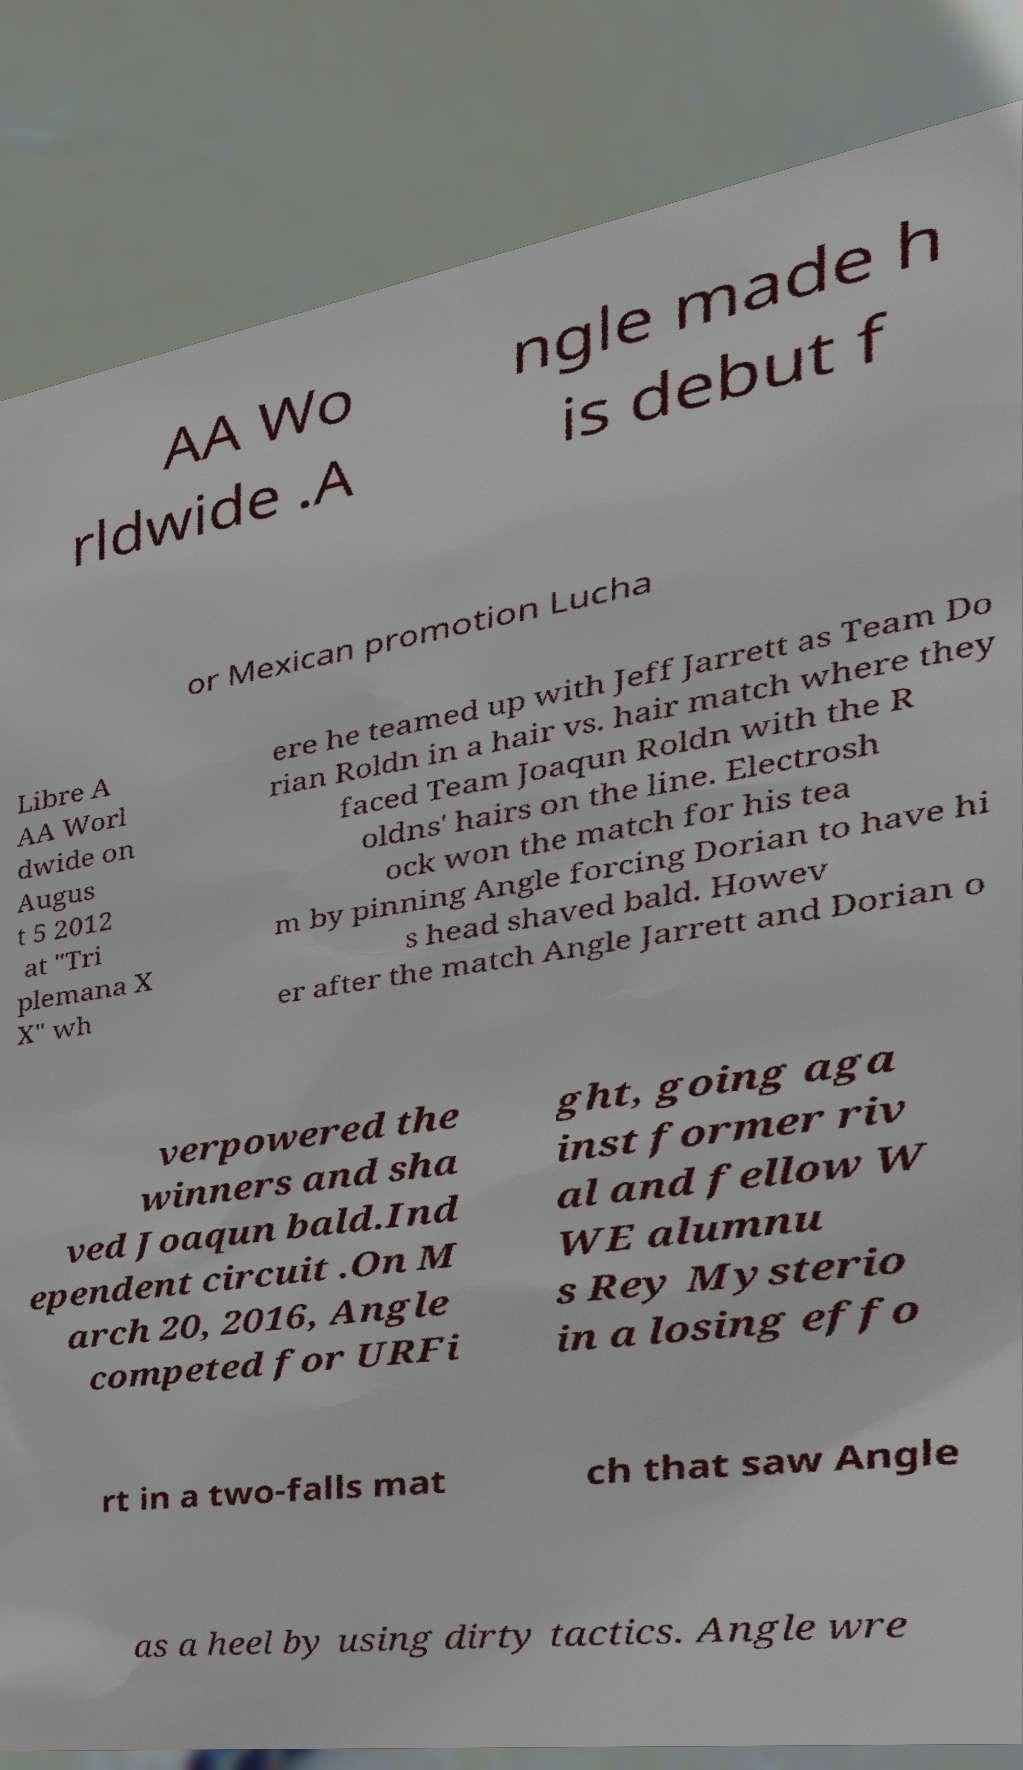I need the written content from this picture converted into text. Can you do that? AA Wo rldwide .A ngle made h is debut f or Mexican promotion Lucha Libre A AA Worl dwide on Augus t 5 2012 at "Tri plemana X X" wh ere he teamed up with Jeff Jarrett as Team Do rian Roldn in a hair vs. hair match where they faced Team Joaqun Roldn with the R oldns' hairs on the line. Electrosh ock won the match for his tea m by pinning Angle forcing Dorian to have hi s head shaved bald. Howev er after the match Angle Jarrett and Dorian o verpowered the winners and sha ved Joaqun bald.Ind ependent circuit .On M arch 20, 2016, Angle competed for URFi ght, going aga inst former riv al and fellow W WE alumnu s Rey Mysterio in a losing effo rt in a two-falls mat ch that saw Angle as a heel by using dirty tactics. Angle wre 